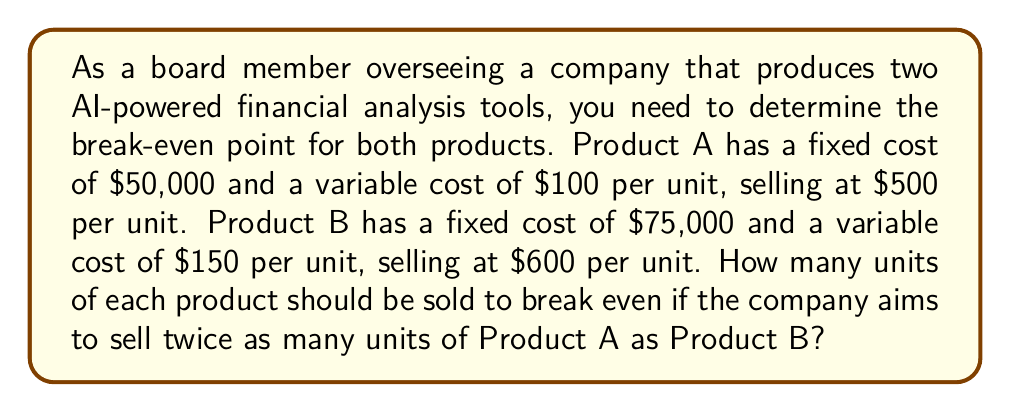Show me your answer to this math problem. Let's approach this step-by-step using a system of equations:

1. Define variables:
   Let $x$ = number of units of Product A
   Let $y$ = number of units of Product B

2. Set up the first equation based on the relationship between x and y:
   $x = 2y$ (Product A sells twice as many units as Product B)

3. Set up the second equation for the break-even point:
   Total Revenue = Total Costs
   $500x + 600y = (50000 + 100x) + (75000 + 150y)$

4. Simplify the second equation:
   $500x + 600y = 125000 + 100x + 150y$
   $400x + 450y = 125000$

5. Substitute $x = 2y$ into the simplified equation:
   $400(2y) + 450y = 125000$
   $800y + 450y = 125000$
   $1250y = 125000$

6. Solve for y:
   $y = 125000 / 1250 = 100$

7. Calculate x:
   $x = 2y = 2(100) = 200$

Therefore, to break even, the company needs to sell 200 units of Product A and 100 units of Product B.

8. Verify the solution:
   Revenue: $500(200) + $600(100) = $100,000 + $60,000 = $160,000
   Costs: $(50000 + 100(200)) + $(75000 + 150(100)) = $70,000 + $90,000 = $160,000

   Revenue equals costs, confirming the break-even point.
Answer: 200 units of Product A and 100 units of Product B 